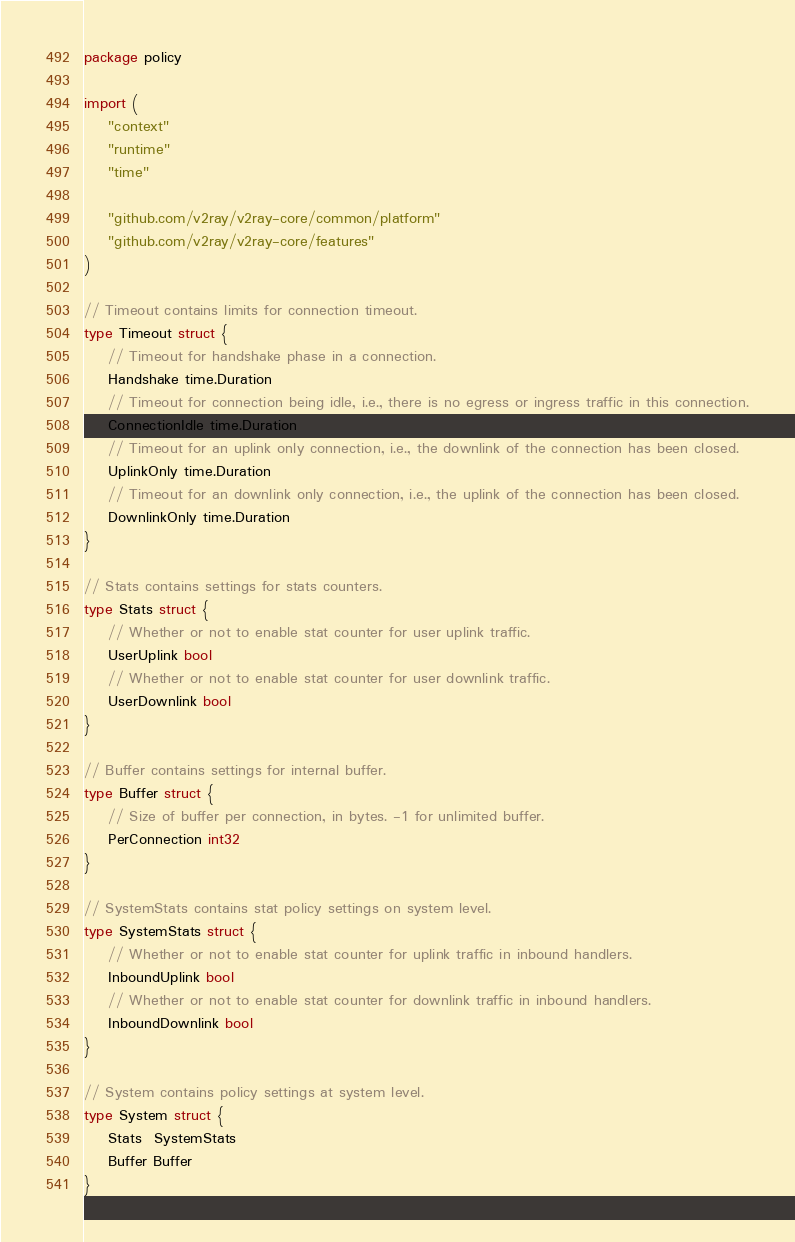<code> <loc_0><loc_0><loc_500><loc_500><_Go_>package policy

import (
	"context"
	"runtime"
	"time"

	"github.com/v2ray/v2ray-core/common/platform"
	"github.com/v2ray/v2ray-core/features"
)

// Timeout contains limits for connection timeout.
type Timeout struct {
	// Timeout for handshake phase in a connection.
	Handshake time.Duration
	// Timeout for connection being idle, i.e., there is no egress or ingress traffic in this connection.
	ConnectionIdle time.Duration
	// Timeout for an uplink only connection, i.e., the downlink of the connection has been closed.
	UplinkOnly time.Duration
	// Timeout for an downlink only connection, i.e., the uplink of the connection has been closed.
	DownlinkOnly time.Duration
}

// Stats contains settings for stats counters.
type Stats struct {
	// Whether or not to enable stat counter for user uplink traffic.
	UserUplink bool
	// Whether or not to enable stat counter for user downlink traffic.
	UserDownlink bool
}

// Buffer contains settings for internal buffer.
type Buffer struct {
	// Size of buffer per connection, in bytes. -1 for unlimited buffer.
	PerConnection int32
}

// SystemStats contains stat policy settings on system level.
type SystemStats struct {
	// Whether or not to enable stat counter for uplink traffic in inbound handlers.
	InboundUplink bool
	// Whether or not to enable stat counter for downlink traffic in inbound handlers.
	InboundDownlink bool
}

// System contains policy settings at system level.
type System struct {
	Stats  SystemStats
	Buffer Buffer
}
</code> 